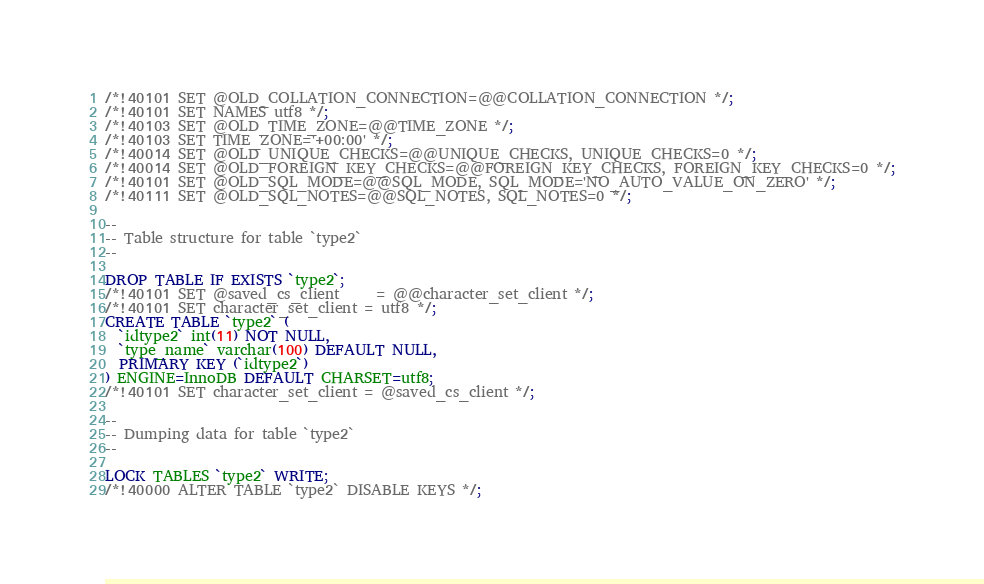Convert code to text. <code><loc_0><loc_0><loc_500><loc_500><_SQL_>/*!40101 SET @OLD_COLLATION_CONNECTION=@@COLLATION_CONNECTION */;
/*!40101 SET NAMES utf8 */;
/*!40103 SET @OLD_TIME_ZONE=@@TIME_ZONE */;
/*!40103 SET TIME_ZONE='+00:00' */;
/*!40014 SET @OLD_UNIQUE_CHECKS=@@UNIQUE_CHECKS, UNIQUE_CHECKS=0 */;
/*!40014 SET @OLD_FOREIGN_KEY_CHECKS=@@FOREIGN_KEY_CHECKS, FOREIGN_KEY_CHECKS=0 */;
/*!40101 SET @OLD_SQL_MODE=@@SQL_MODE, SQL_MODE='NO_AUTO_VALUE_ON_ZERO' */;
/*!40111 SET @OLD_SQL_NOTES=@@SQL_NOTES, SQL_NOTES=0 */;

--
-- Table structure for table `type2`
--

DROP TABLE IF EXISTS `type2`;
/*!40101 SET @saved_cs_client     = @@character_set_client */;
/*!40101 SET character_set_client = utf8 */;
CREATE TABLE `type2` (
  `idtype2` int(11) NOT NULL,
  `type_name` varchar(100) DEFAULT NULL,
  PRIMARY KEY (`idtype2`)
) ENGINE=InnoDB DEFAULT CHARSET=utf8;
/*!40101 SET character_set_client = @saved_cs_client */;

--
-- Dumping data for table `type2`
--

LOCK TABLES `type2` WRITE;
/*!40000 ALTER TABLE `type2` DISABLE KEYS */;</code> 